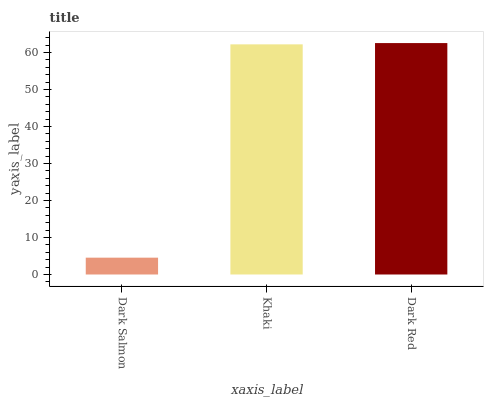Is Dark Salmon the minimum?
Answer yes or no. Yes. Is Dark Red the maximum?
Answer yes or no. Yes. Is Khaki the minimum?
Answer yes or no. No. Is Khaki the maximum?
Answer yes or no. No. Is Khaki greater than Dark Salmon?
Answer yes or no. Yes. Is Dark Salmon less than Khaki?
Answer yes or no. Yes. Is Dark Salmon greater than Khaki?
Answer yes or no. No. Is Khaki less than Dark Salmon?
Answer yes or no. No. Is Khaki the high median?
Answer yes or no. Yes. Is Khaki the low median?
Answer yes or no. Yes. Is Dark Red the high median?
Answer yes or no. No. Is Dark Red the low median?
Answer yes or no. No. 